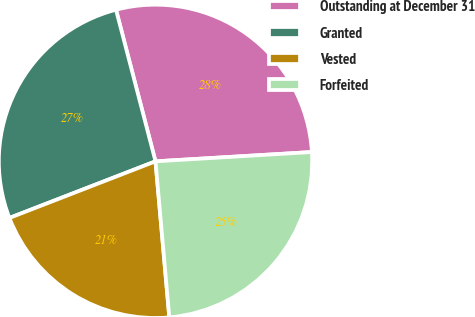<chart> <loc_0><loc_0><loc_500><loc_500><pie_chart><fcel>Outstanding at December 31<fcel>Granted<fcel>Vested<fcel>Forfeited<nl><fcel>28.11%<fcel>26.83%<fcel>20.52%<fcel>24.54%<nl></chart> 